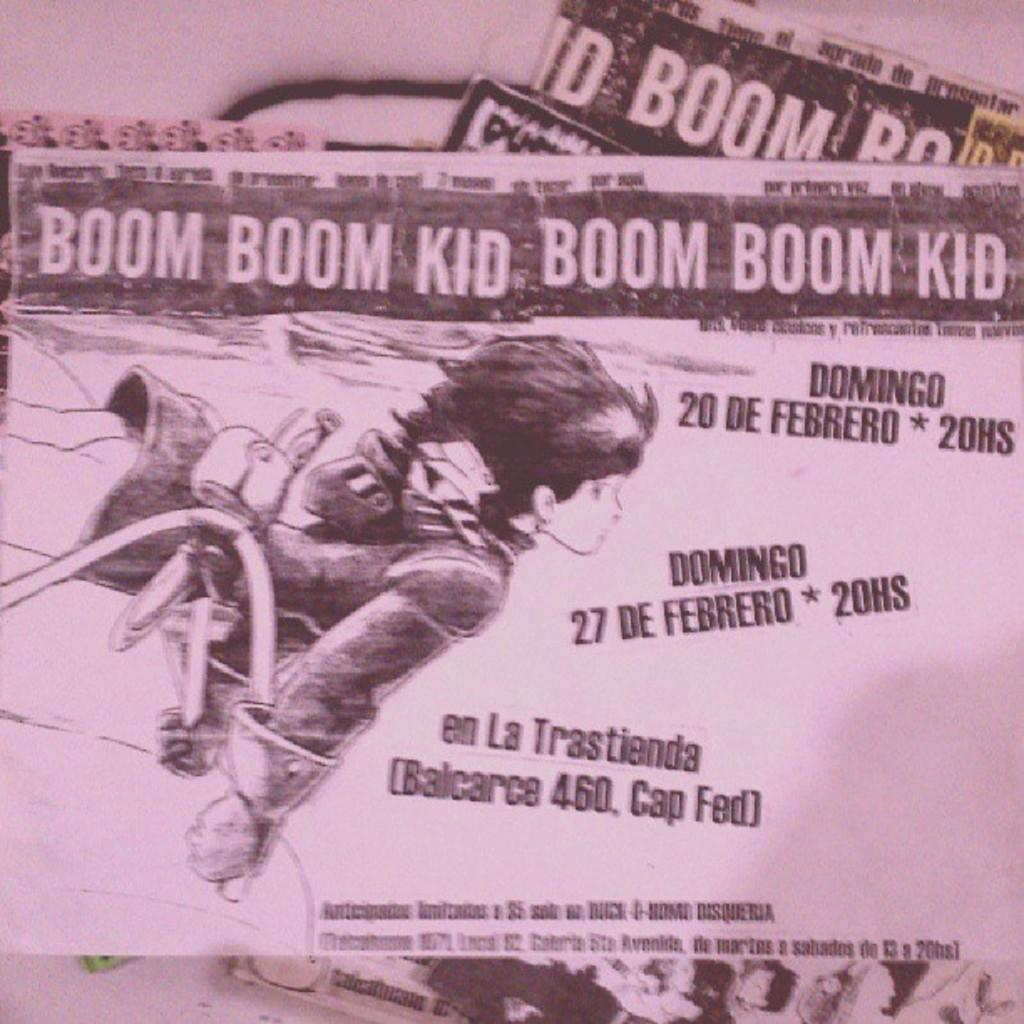What is located on the left side of the image? There is a person on the left side of the image. What is the person doing in the image? The person is holding an object. What can be seen in the background of the image? There is text visible in the background of the image. How many crates are visible in the image? There are no crates present in the image. What type of bun is being held by the person in the image? The person is not holding a bun in the image; they are holding an unspecified object. 